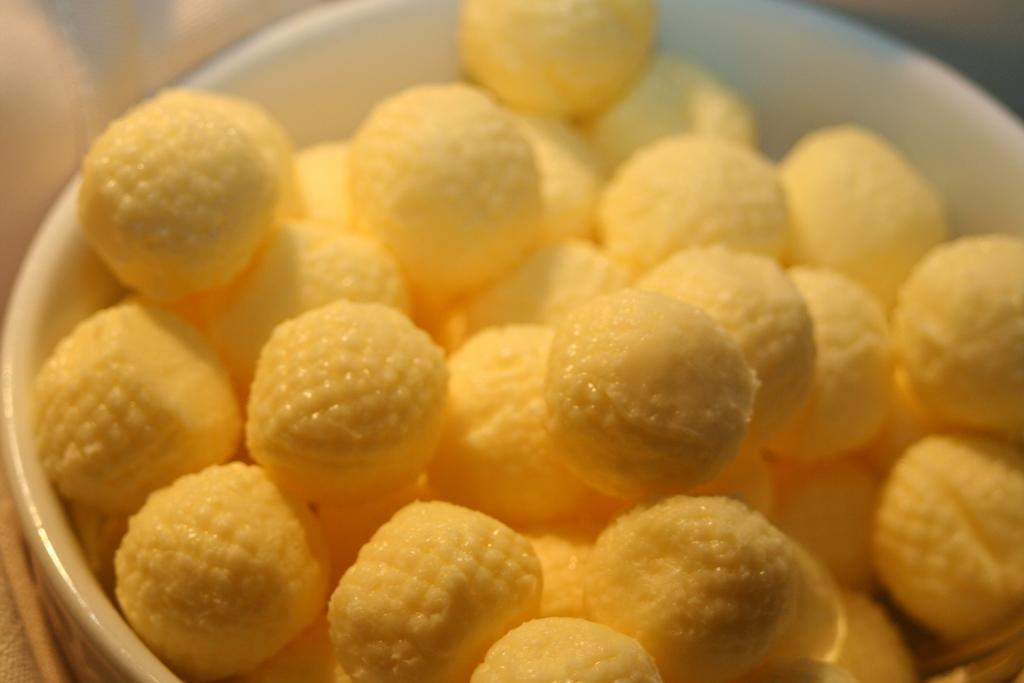Please provide a concise description of this image. In this image I can see the bowl with the food. The bowl is in white color and the food is in yellow color. 